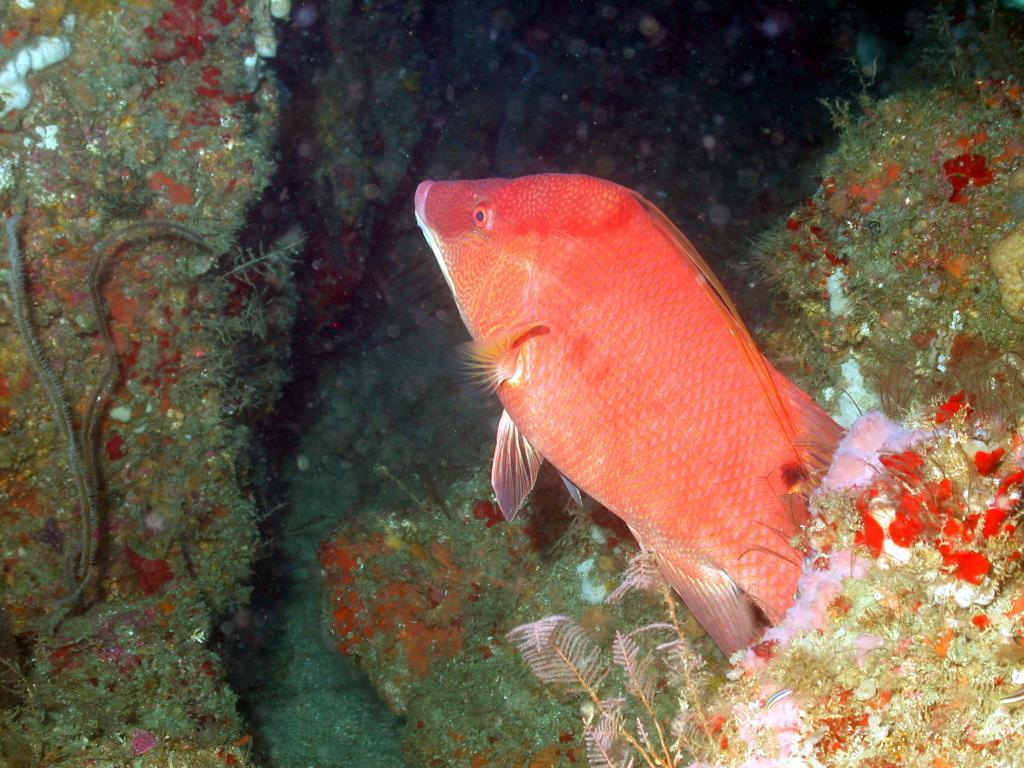What is the main subject of the picture? The main subject of the picture is a fish. Can you describe the color of the fish? The fish is red in color. What else can be seen in the picture besides the fish? There are plants in the picture. How much water is in the stream that the fish is swimming in? There is no stream present in the image, and therefore no water for the fish to swim in. 